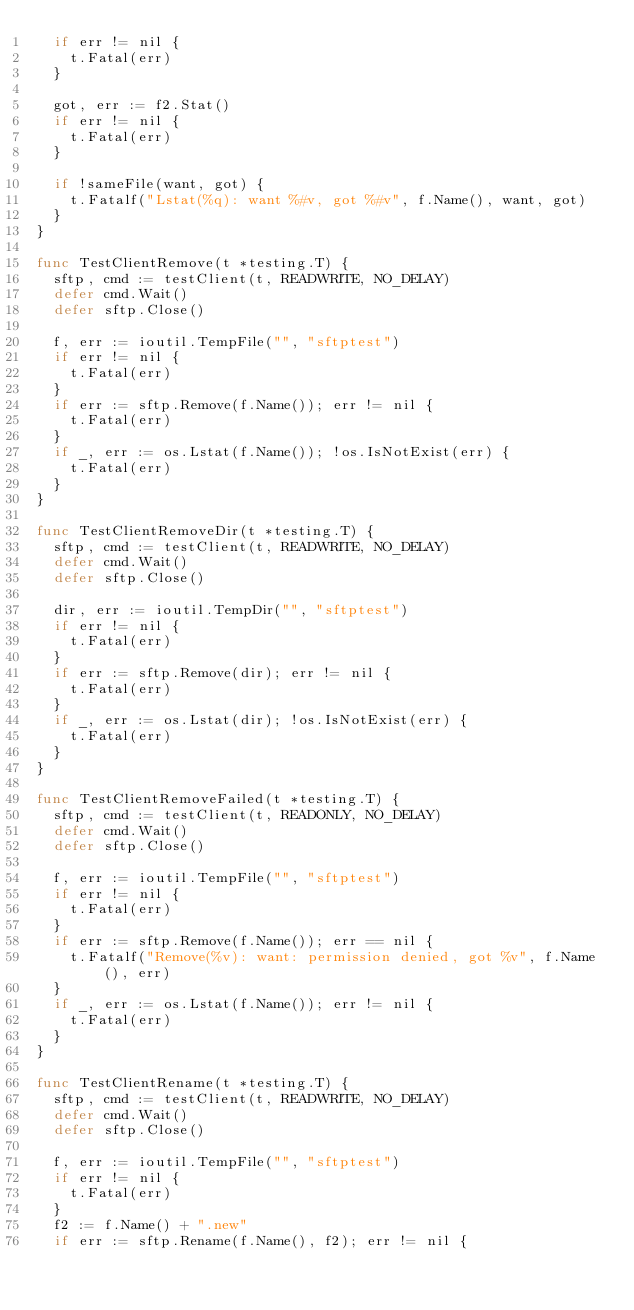<code> <loc_0><loc_0><loc_500><loc_500><_Go_>	if err != nil {
		t.Fatal(err)
	}

	got, err := f2.Stat()
	if err != nil {
		t.Fatal(err)
	}

	if !sameFile(want, got) {
		t.Fatalf("Lstat(%q): want %#v, got %#v", f.Name(), want, got)
	}
}

func TestClientRemove(t *testing.T) {
	sftp, cmd := testClient(t, READWRITE, NO_DELAY)
	defer cmd.Wait()
	defer sftp.Close()

	f, err := ioutil.TempFile("", "sftptest")
	if err != nil {
		t.Fatal(err)
	}
	if err := sftp.Remove(f.Name()); err != nil {
		t.Fatal(err)
	}
	if _, err := os.Lstat(f.Name()); !os.IsNotExist(err) {
		t.Fatal(err)
	}
}

func TestClientRemoveDir(t *testing.T) {
	sftp, cmd := testClient(t, READWRITE, NO_DELAY)
	defer cmd.Wait()
	defer sftp.Close()

	dir, err := ioutil.TempDir("", "sftptest")
	if err != nil {
		t.Fatal(err)
	}
	if err := sftp.Remove(dir); err != nil {
		t.Fatal(err)
	}
	if _, err := os.Lstat(dir); !os.IsNotExist(err) {
		t.Fatal(err)
	}
}

func TestClientRemoveFailed(t *testing.T) {
	sftp, cmd := testClient(t, READONLY, NO_DELAY)
	defer cmd.Wait()
	defer sftp.Close()

	f, err := ioutil.TempFile("", "sftptest")
	if err != nil {
		t.Fatal(err)
	}
	if err := sftp.Remove(f.Name()); err == nil {
		t.Fatalf("Remove(%v): want: permission denied, got %v", f.Name(), err)
	}
	if _, err := os.Lstat(f.Name()); err != nil {
		t.Fatal(err)
	}
}

func TestClientRename(t *testing.T) {
	sftp, cmd := testClient(t, READWRITE, NO_DELAY)
	defer cmd.Wait()
	defer sftp.Close()

	f, err := ioutil.TempFile("", "sftptest")
	if err != nil {
		t.Fatal(err)
	}
	f2 := f.Name() + ".new"
	if err := sftp.Rename(f.Name(), f2); err != nil {</code> 